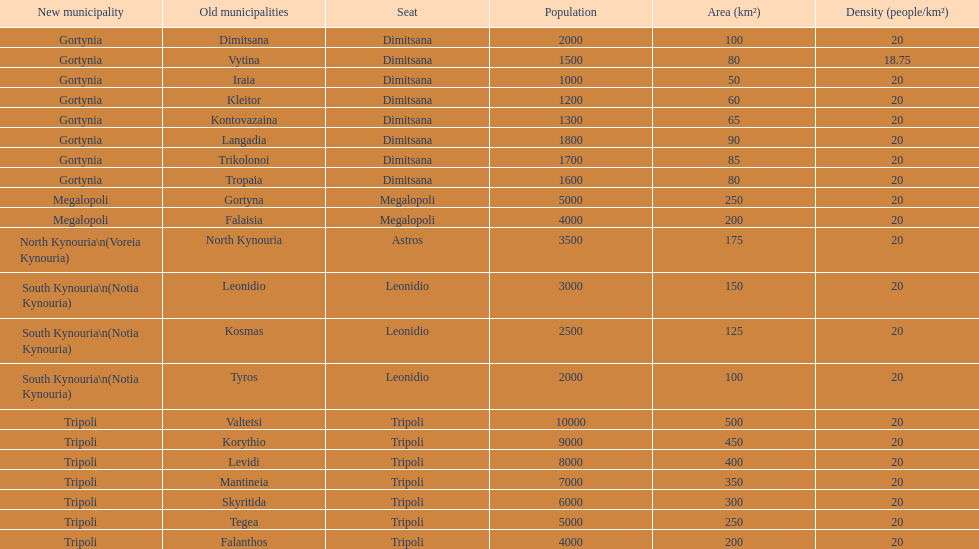What is the recently established municipality in tyros? South Kynouria. 